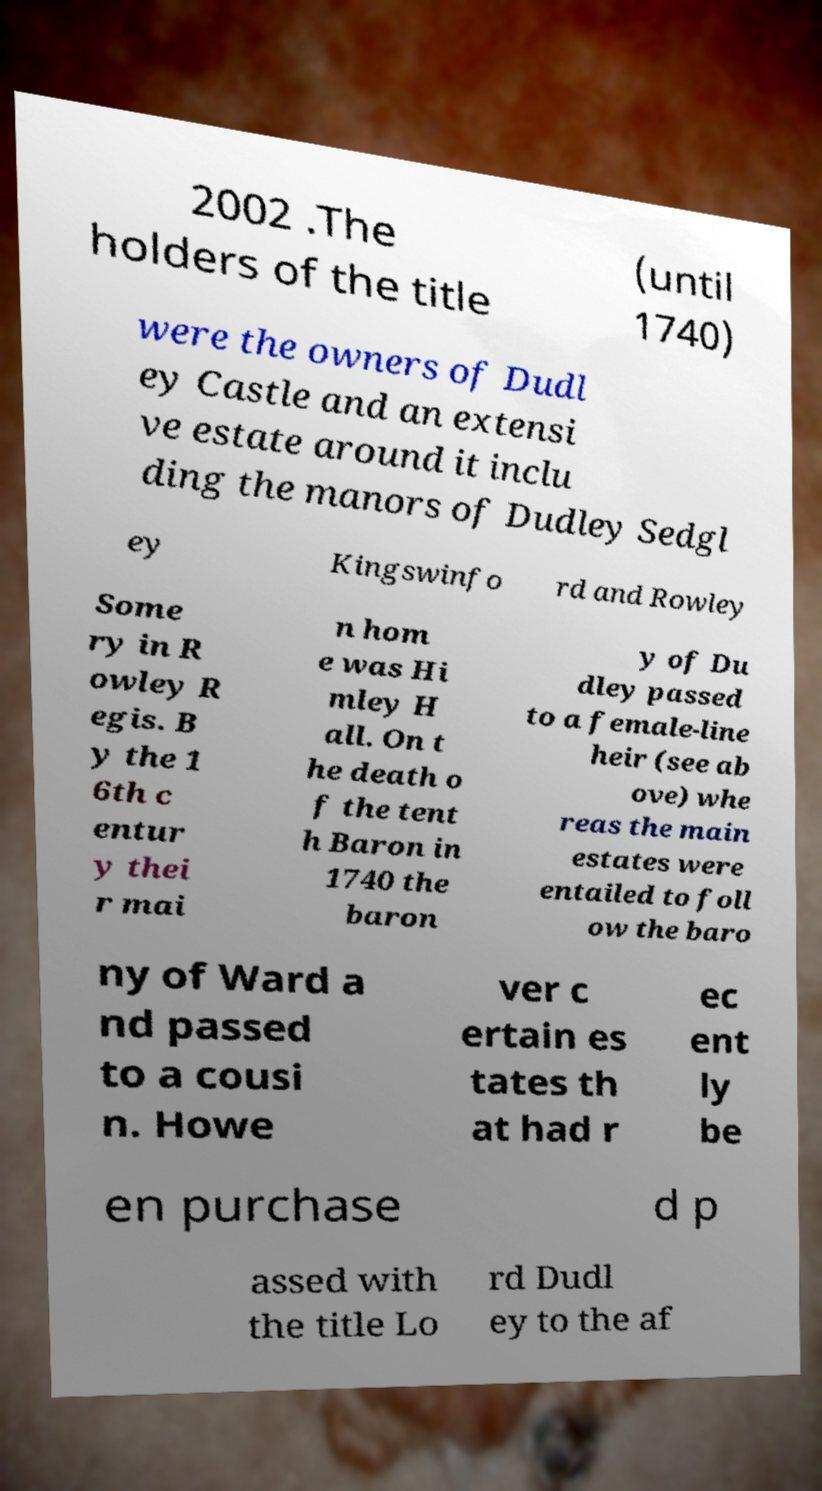There's text embedded in this image that I need extracted. Can you transcribe it verbatim? 2002 .The holders of the title (until 1740) were the owners of Dudl ey Castle and an extensi ve estate around it inclu ding the manors of Dudley Sedgl ey Kingswinfo rd and Rowley Some ry in R owley R egis. B y the 1 6th c entur y thei r mai n hom e was Hi mley H all. On t he death o f the tent h Baron in 1740 the baron y of Du dley passed to a female-line heir (see ab ove) whe reas the main estates were entailed to foll ow the baro ny of Ward a nd passed to a cousi n. Howe ver c ertain es tates th at had r ec ent ly be en purchase d p assed with the title Lo rd Dudl ey to the af 